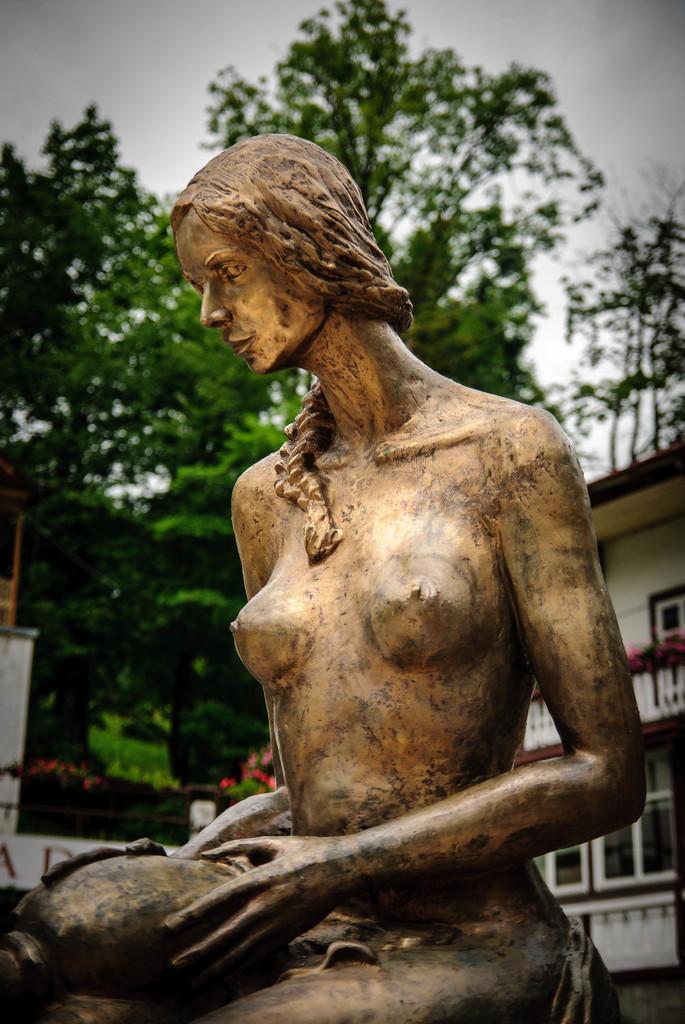In one or two sentences, can you explain what this image depicts? In this image there is a statue of a woman present in the middle of this image. There is a building on the right side of this image and there are some trees in the background. There is a sky at the top of this image. 